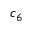<formula> <loc_0><loc_0><loc_500><loc_500>c _ { 6 }</formula> 